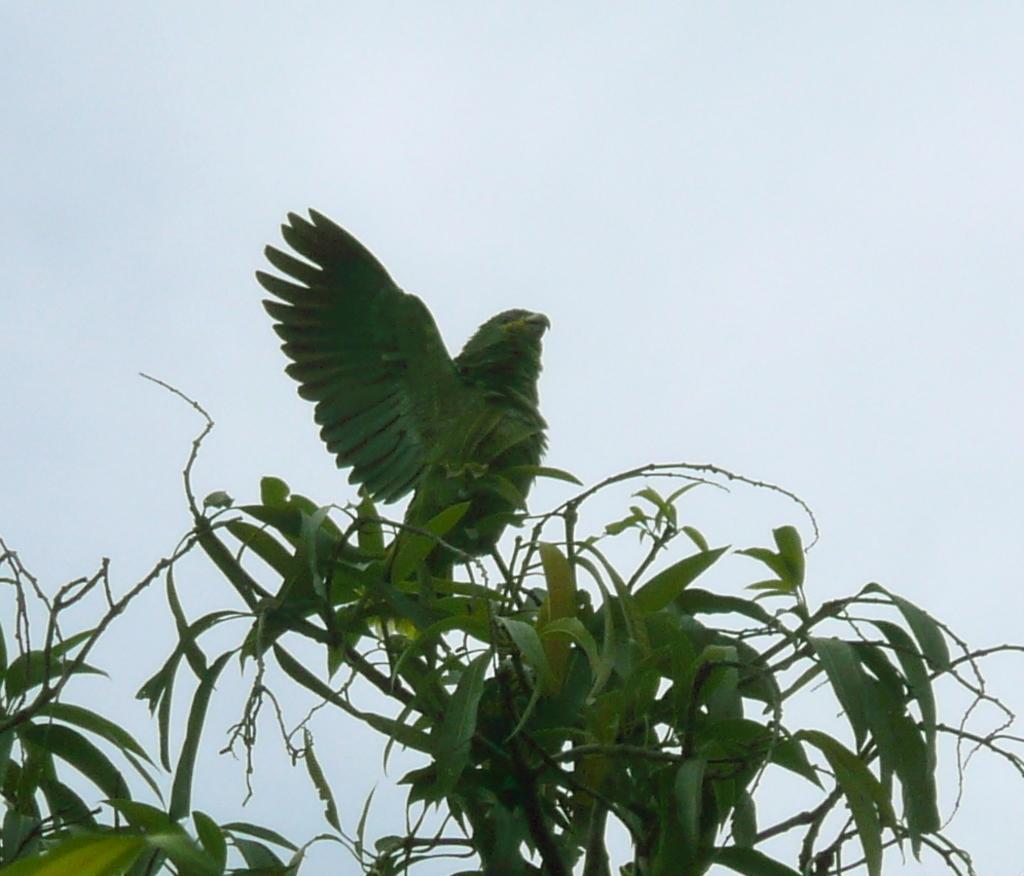Describe this image in one or two sentences. In this image we can see green color parrot which is on the branch of a plant and at the top of the image there is clear sky and at the bottom of the image we can see some leaves. 